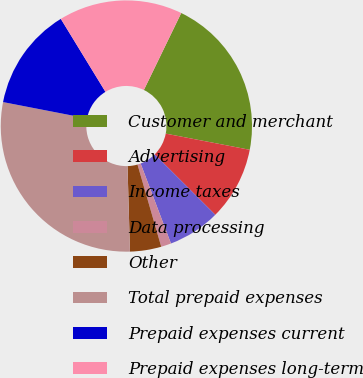Convert chart. <chart><loc_0><loc_0><loc_500><loc_500><pie_chart><fcel>Customer and merchant<fcel>Advertising<fcel>Income taxes<fcel>Data processing<fcel>Other<fcel>Total prepaid expenses<fcel>Prepaid expenses current<fcel>Prepaid expenses long-term<nl><fcel>20.84%<fcel>9.46%<fcel>6.74%<fcel>1.3%<fcel>4.02%<fcel>28.51%<fcel>13.21%<fcel>15.93%<nl></chart> 